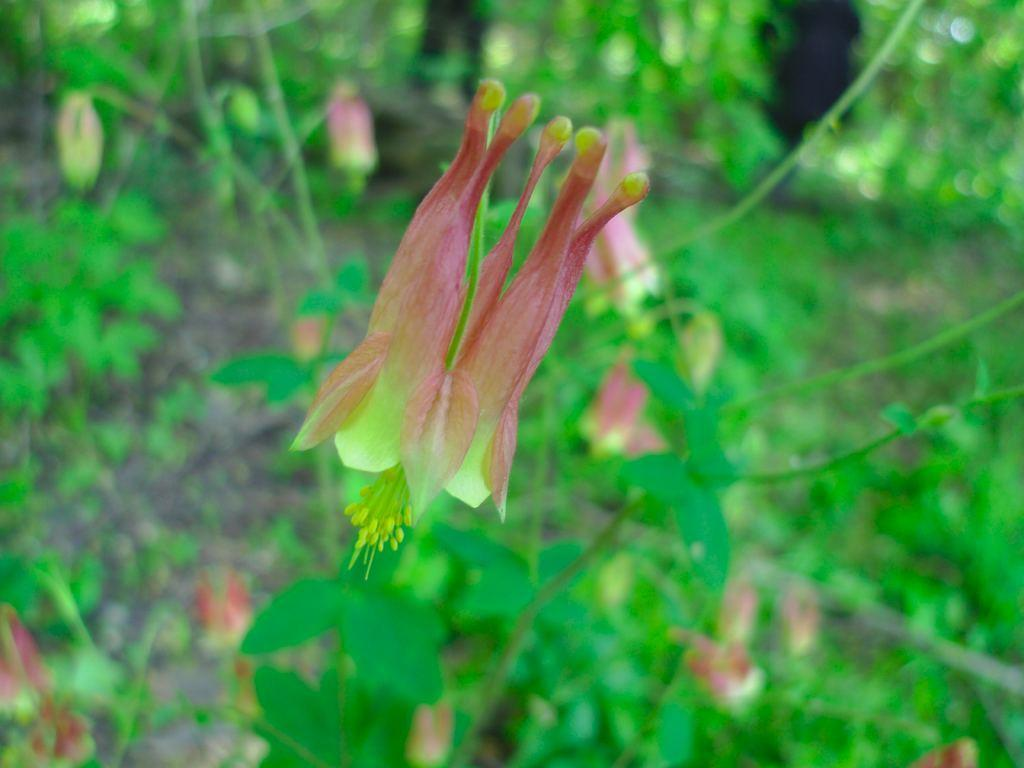What type of plant is visible in the image? There is a flower with petals in the image. Are there any other plants visible in the image? Yes, there are plants with leaves and flowers in the image. How many cats are sitting on the vessel in the image? There are no cats or vessels present in the image. 